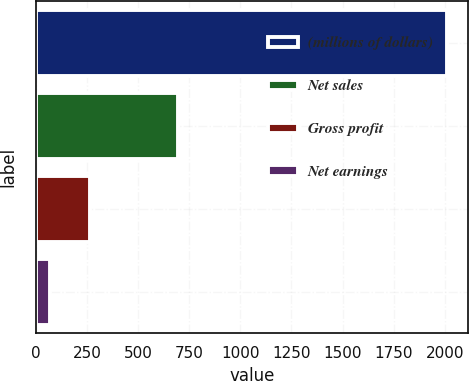Convert chart. <chart><loc_0><loc_0><loc_500><loc_500><bar_chart><fcel>(millions of dollars)<fcel>Net sales<fcel>Gross profit<fcel>Net earnings<nl><fcel>2012<fcel>696.7<fcel>262.85<fcel>68.5<nl></chart> 